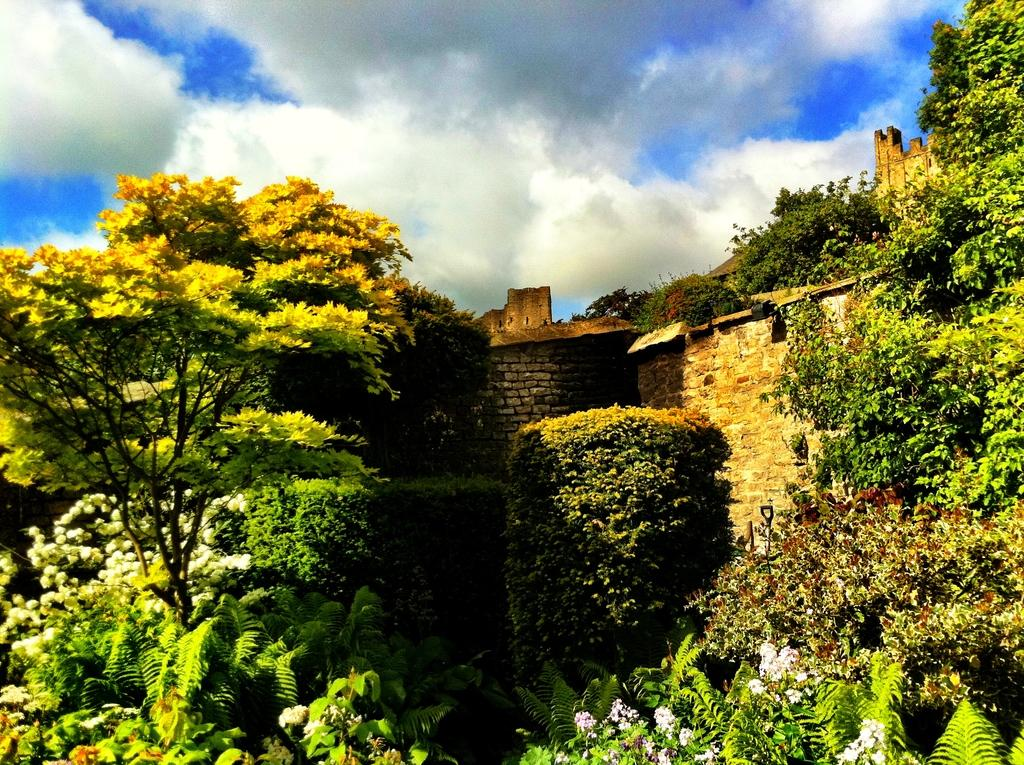What type of vegetation can be seen in the image? There are trees in the image. What type of structure is present in the image? There is a stone building in the image. What is visible in the sky in the image? There are clouds in the sky in the image. How many rabbits can be seen playing on the arch in the image? There are no rabbits or arches present in the image. What type of joke is being told by the clouds in the image? There are no jokes or any indication of humor in the image; it simply features trees, a stone building, and clouds in the sky. 